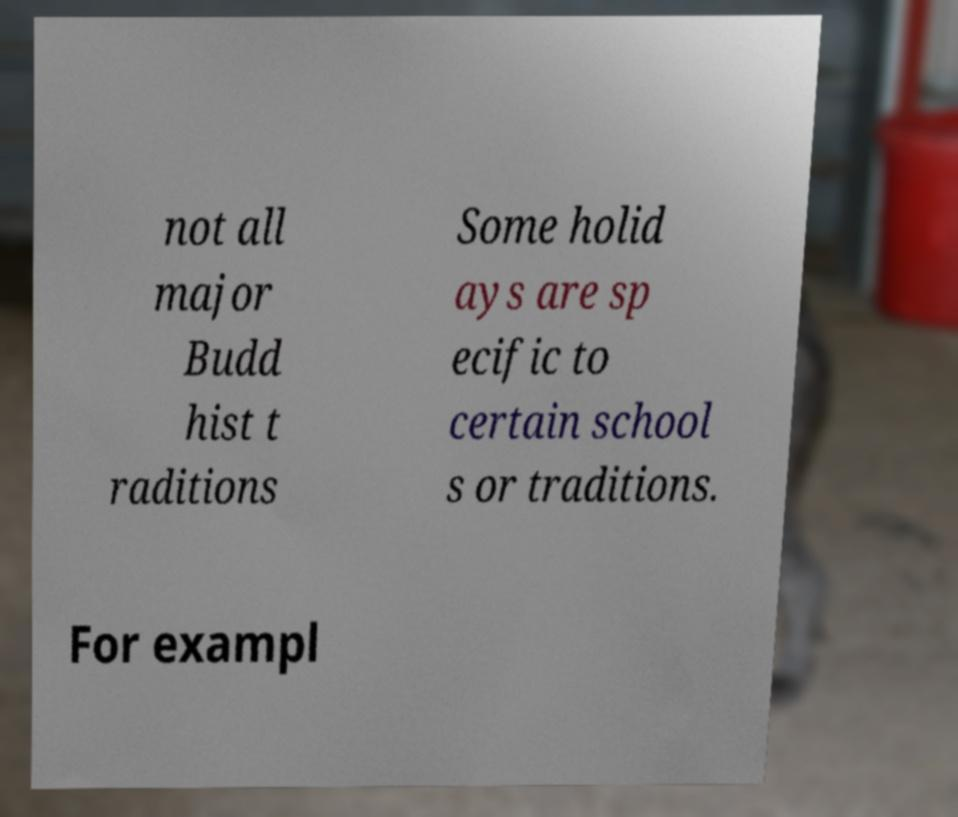For documentation purposes, I need the text within this image transcribed. Could you provide that? not all major Budd hist t raditions Some holid ays are sp ecific to certain school s or traditions. For exampl 